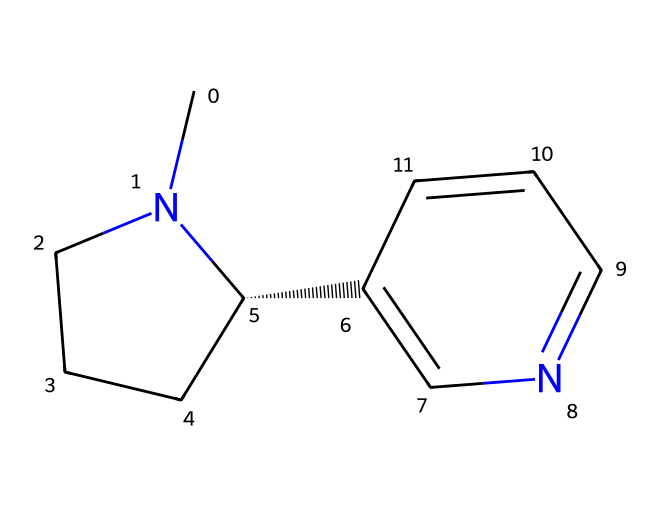How many nitrogen atoms are present in this chemical? By examining the SMILES notation, we can identify the nitrogen atoms represented by 'N'. In the provided structure, there are two occurrences of 'N', indicating that there are 2 nitrogen atoms.
Answer: 2 What type of chemical is depicted by the SMILES representation? The chemical structure represents an alkaloid, characterized by its basic nitrogen atoms that are part of a complex ring structure, which is typical for alkaloids.
Answer: alkaloid How many carbon atoms are in the molecular structure? In analyzing the SMILES, we count the number of carbon atoms denoted by 'C'. The representation indicates that there are 10 carbon atoms in total in the structure.
Answer: 10 Identify the type of bond primarily present in the structure. The structure contains sigma (σ) bonds and pi (π) bonds, but the most significant type present is the sigma bond, as it forms the backbone of the molecular structure.
Answer: sigma What is the functional group commonly associated with nicotine? The nitrogen atom in the structure is a part of a pyridine ring and contributes to the presence of the amino group, which is characteristic of nicotine's reactivity and pharmacological properties.
Answer: amino group 